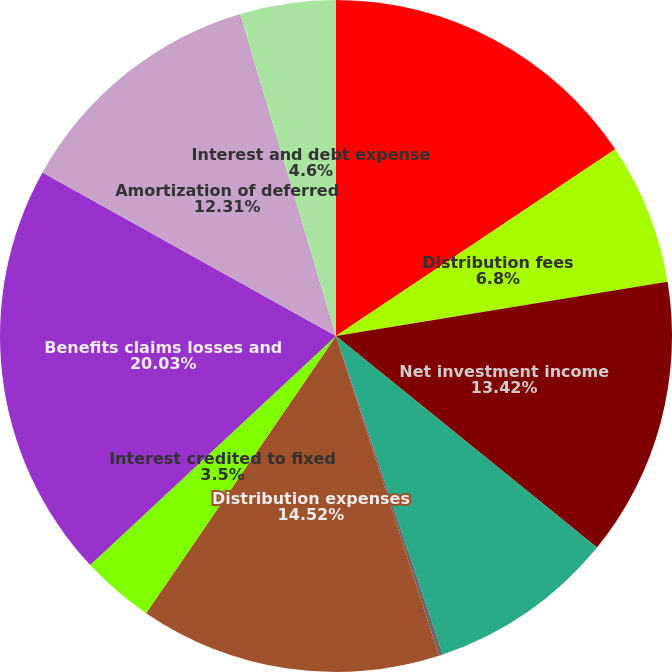<chart> <loc_0><loc_0><loc_500><loc_500><pie_chart><fcel>Management and financial<fcel>Distribution fees<fcel>Net investment income<fcel>Other revenues<fcel>Banking and deposit interest<fcel>Distribution expenses<fcel>Interest credited to fixed<fcel>Benefits claims losses and<fcel>Amortization of deferred<fcel>Interest and debt expense<nl><fcel>15.62%<fcel>6.8%<fcel>13.42%<fcel>9.01%<fcel>0.19%<fcel>14.52%<fcel>3.5%<fcel>20.03%<fcel>12.31%<fcel>4.6%<nl></chart> 